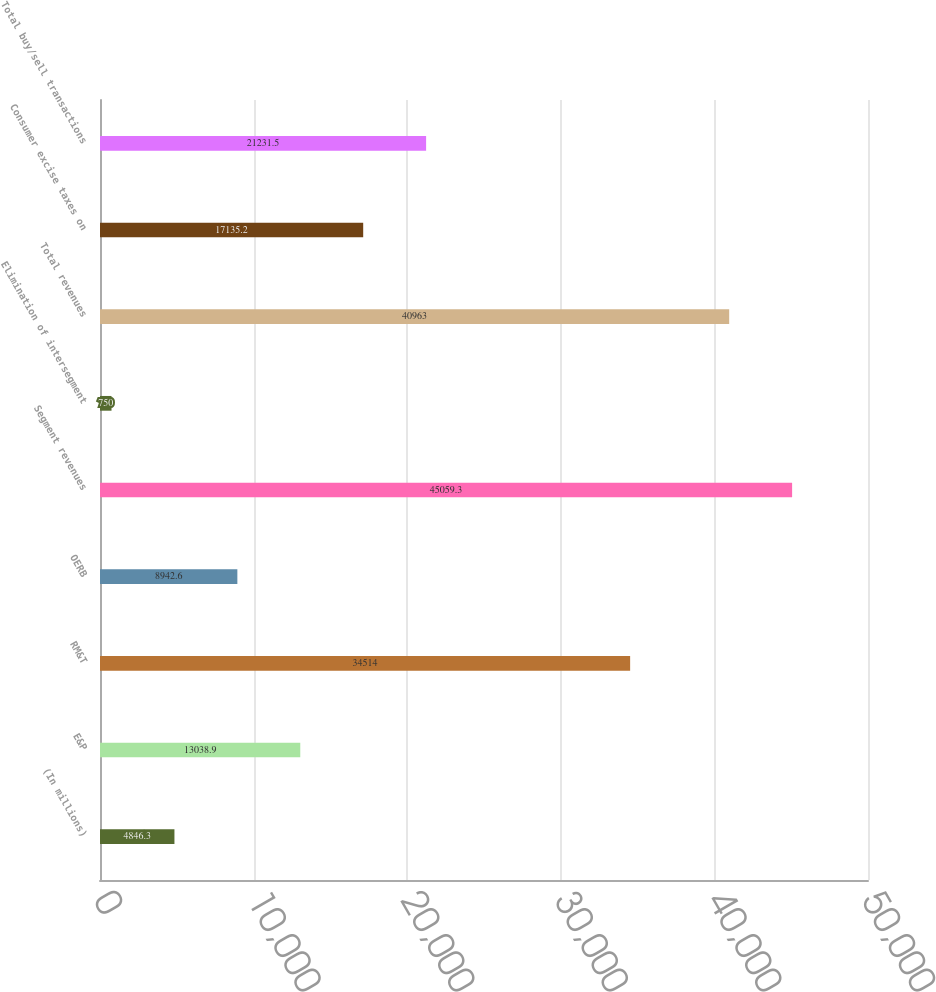<chart> <loc_0><loc_0><loc_500><loc_500><bar_chart><fcel>(In millions)<fcel>E&P<fcel>RM&T<fcel>OERB<fcel>Segment revenues<fcel>Elimination of intersegment<fcel>Total revenues<fcel>Consumer excise taxes on<fcel>Total buy/sell transactions<nl><fcel>4846.3<fcel>13038.9<fcel>34514<fcel>8942.6<fcel>45059.3<fcel>750<fcel>40963<fcel>17135.2<fcel>21231.5<nl></chart> 